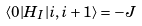<formula> <loc_0><loc_0><loc_500><loc_500>\langle 0 | H _ { I } | i , i + 1 \rangle = - J</formula> 